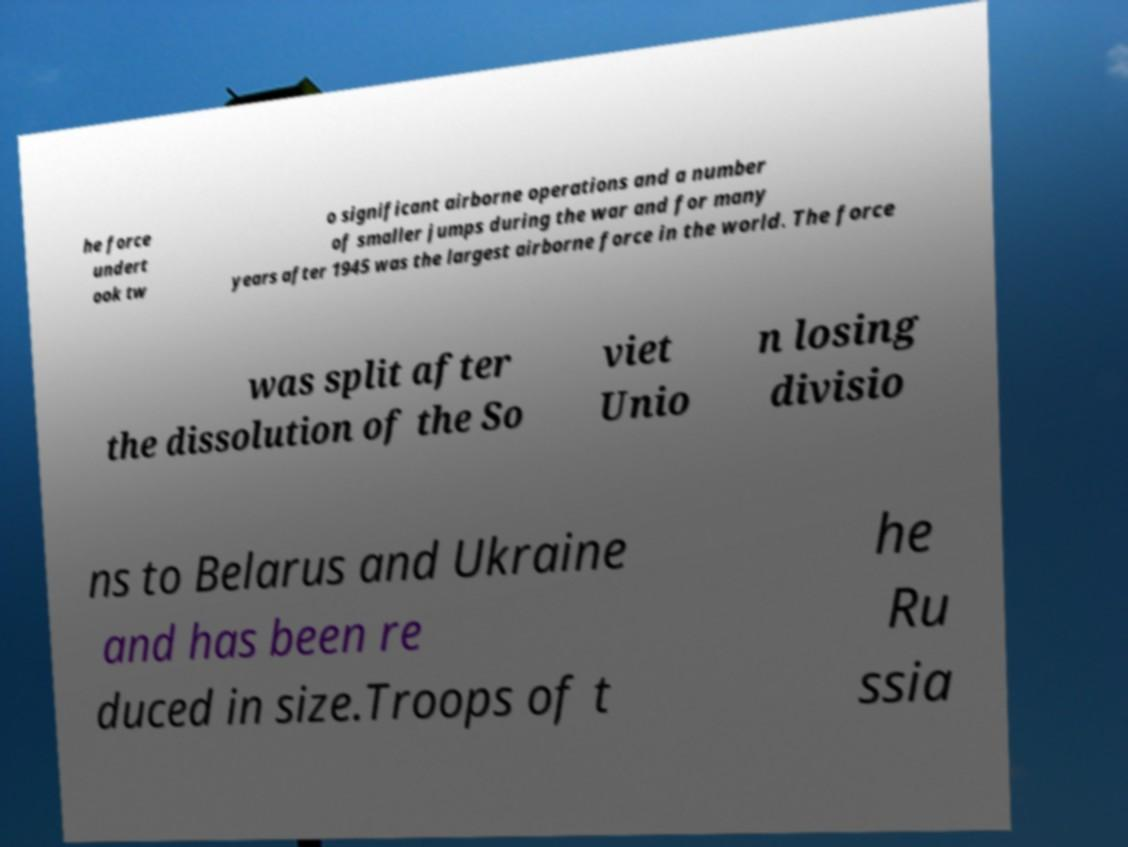There's text embedded in this image that I need extracted. Can you transcribe it verbatim? he force undert ook tw o significant airborne operations and a number of smaller jumps during the war and for many years after 1945 was the largest airborne force in the world. The force was split after the dissolution of the So viet Unio n losing divisio ns to Belarus and Ukraine and has been re duced in size.Troops of t he Ru ssia 